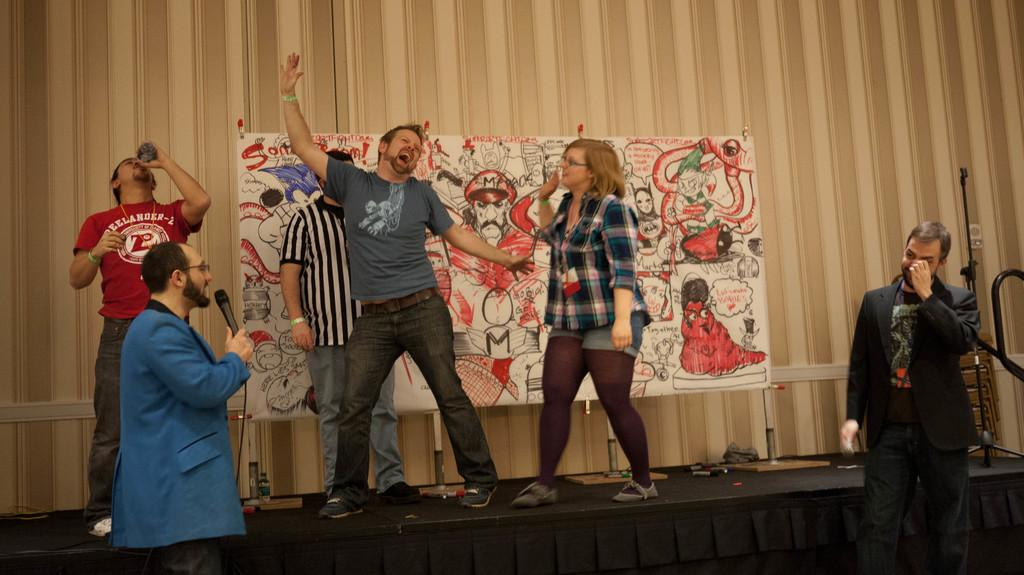How many people are in the image? There are people in the image, but the exact number is not specified. What is one person doing in the image? One person is holding a microphone. What is another person holding in the image? Another person is holding a bottle. What can be seen on the wall in the background of the image? There is a banner on the wall in the background. Can you see a seashore in the image? No, there is no seashore visible in the image. 